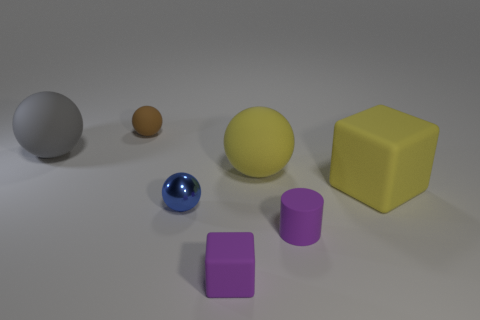There is a rubber cube that is the same color as the small rubber cylinder; what is its size?
Keep it short and to the point. Small. What is the tiny thing that is behind the small sphere in front of the small brown matte sphere made of?
Offer a terse response. Rubber. How many things are either brown balls or objects that are behind the small purple cylinder?
Your answer should be compact. 5. The purple object that is the same material as the purple cylinder is what size?
Offer a terse response. Small. How many blue objects are either tiny spheres or small cylinders?
Give a very brief answer. 1. There is a tiny matte thing that is the same color as the small cylinder; what shape is it?
Make the answer very short. Cube. Are there any other things that have the same material as the tiny blue ball?
Offer a terse response. No. Do the big yellow object that is behind the large cube and the big rubber thing that is left of the blue metallic object have the same shape?
Ensure brevity in your answer.  Yes. What number of metallic spheres are there?
Your answer should be very brief. 1. What is the shape of the large yellow thing that is made of the same material as the yellow block?
Offer a very short reply. Sphere. 